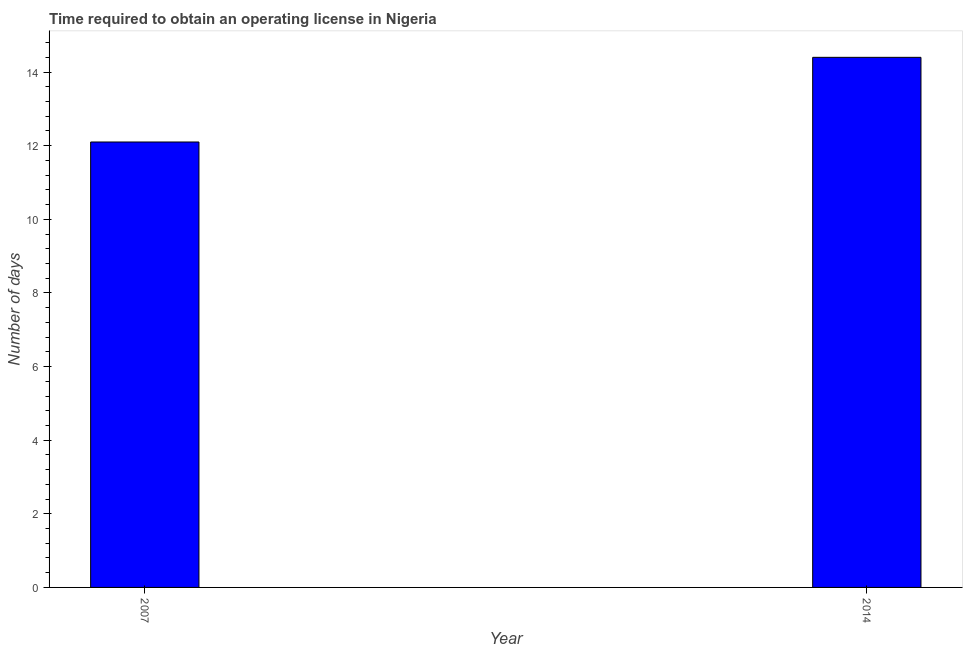Does the graph contain any zero values?
Ensure brevity in your answer.  No. What is the title of the graph?
Offer a very short reply. Time required to obtain an operating license in Nigeria. What is the label or title of the Y-axis?
Your response must be concise. Number of days. Across all years, what is the maximum number of days to obtain operating license?
Your response must be concise. 14.4. In which year was the number of days to obtain operating license maximum?
Make the answer very short. 2014. In which year was the number of days to obtain operating license minimum?
Make the answer very short. 2007. What is the average number of days to obtain operating license per year?
Provide a short and direct response. 13.25. What is the median number of days to obtain operating license?
Your answer should be very brief. 13.25. In how many years, is the number of days to obtain operating license greater than 13.2 days?
Ensure brevity in your answer.  1. What is the ratio of the number of days to obtain operating license in 2007 to that in 2014?
Ensure brevity in your answer.  0.84. Is the number of days to obtain operating license in 2007 less than that in 2014?
Make the answer very short. Yes. Are all the bars in the graph horizontal?
Your answer should be compact. No. What is the Number of days of 2014?
Make the answer very short. 14.4. What is the difference between the Number of days in 2007 and 2014?
Your answer should be compact. -2.3. What is the ratio of the Number of days in 2007 to that in 2014?
Provide a short and direct response. 0.84. 